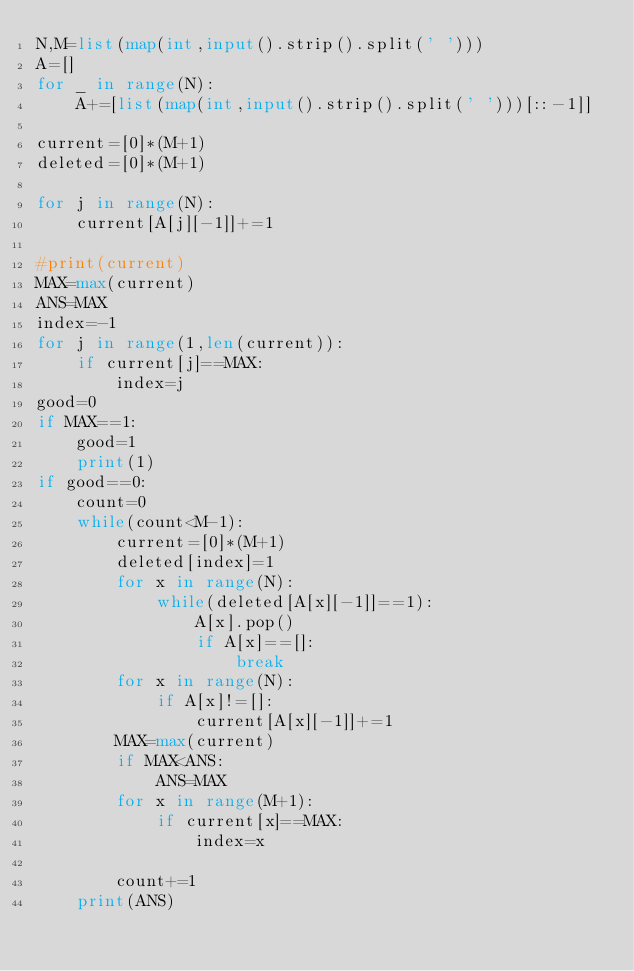Convert code to text. <code><loc_0><loc_0><loc_500><loc_500><_Python_>N,M=list(map(int,input().strip().split(' ')))
A=[]
for _ in range(N):
    A+=[list(map(int,input().strip().split(' ')))[::-1]]
    
current=[0]*(M+1)
deleted=[0]*(M+1)

for j in range(N):
    current[A[j][-1]]+=1
    
#print(current)    
MAX=max(current)
ANS=MAX
index=-1
for j in range(1,len(current)):
    if current[j]==MAX:
        index=j
good=0       
if MAX==1:
    good=1
    print(1)
if good==0:
    count=0
    while(count<M-1):
        current=[0]*(M+1)
        deleted[index]=1
        for x in range(N):
            while(deleted[A[x][-1]]==1):
                A[x].pop()
                if A[x]==[]:
                    break
        for x in range(N):
            if A[x]!=[]:
                current[A[x][-1]]+=1
        MAX=max(current)
        if MAX<ANS:
            ANS=MAX
        for x in range(M+1):
            if current[x]==MAX:
                index=x
                
        count+=1  
    print(ANS)    
            
                
        </code> 